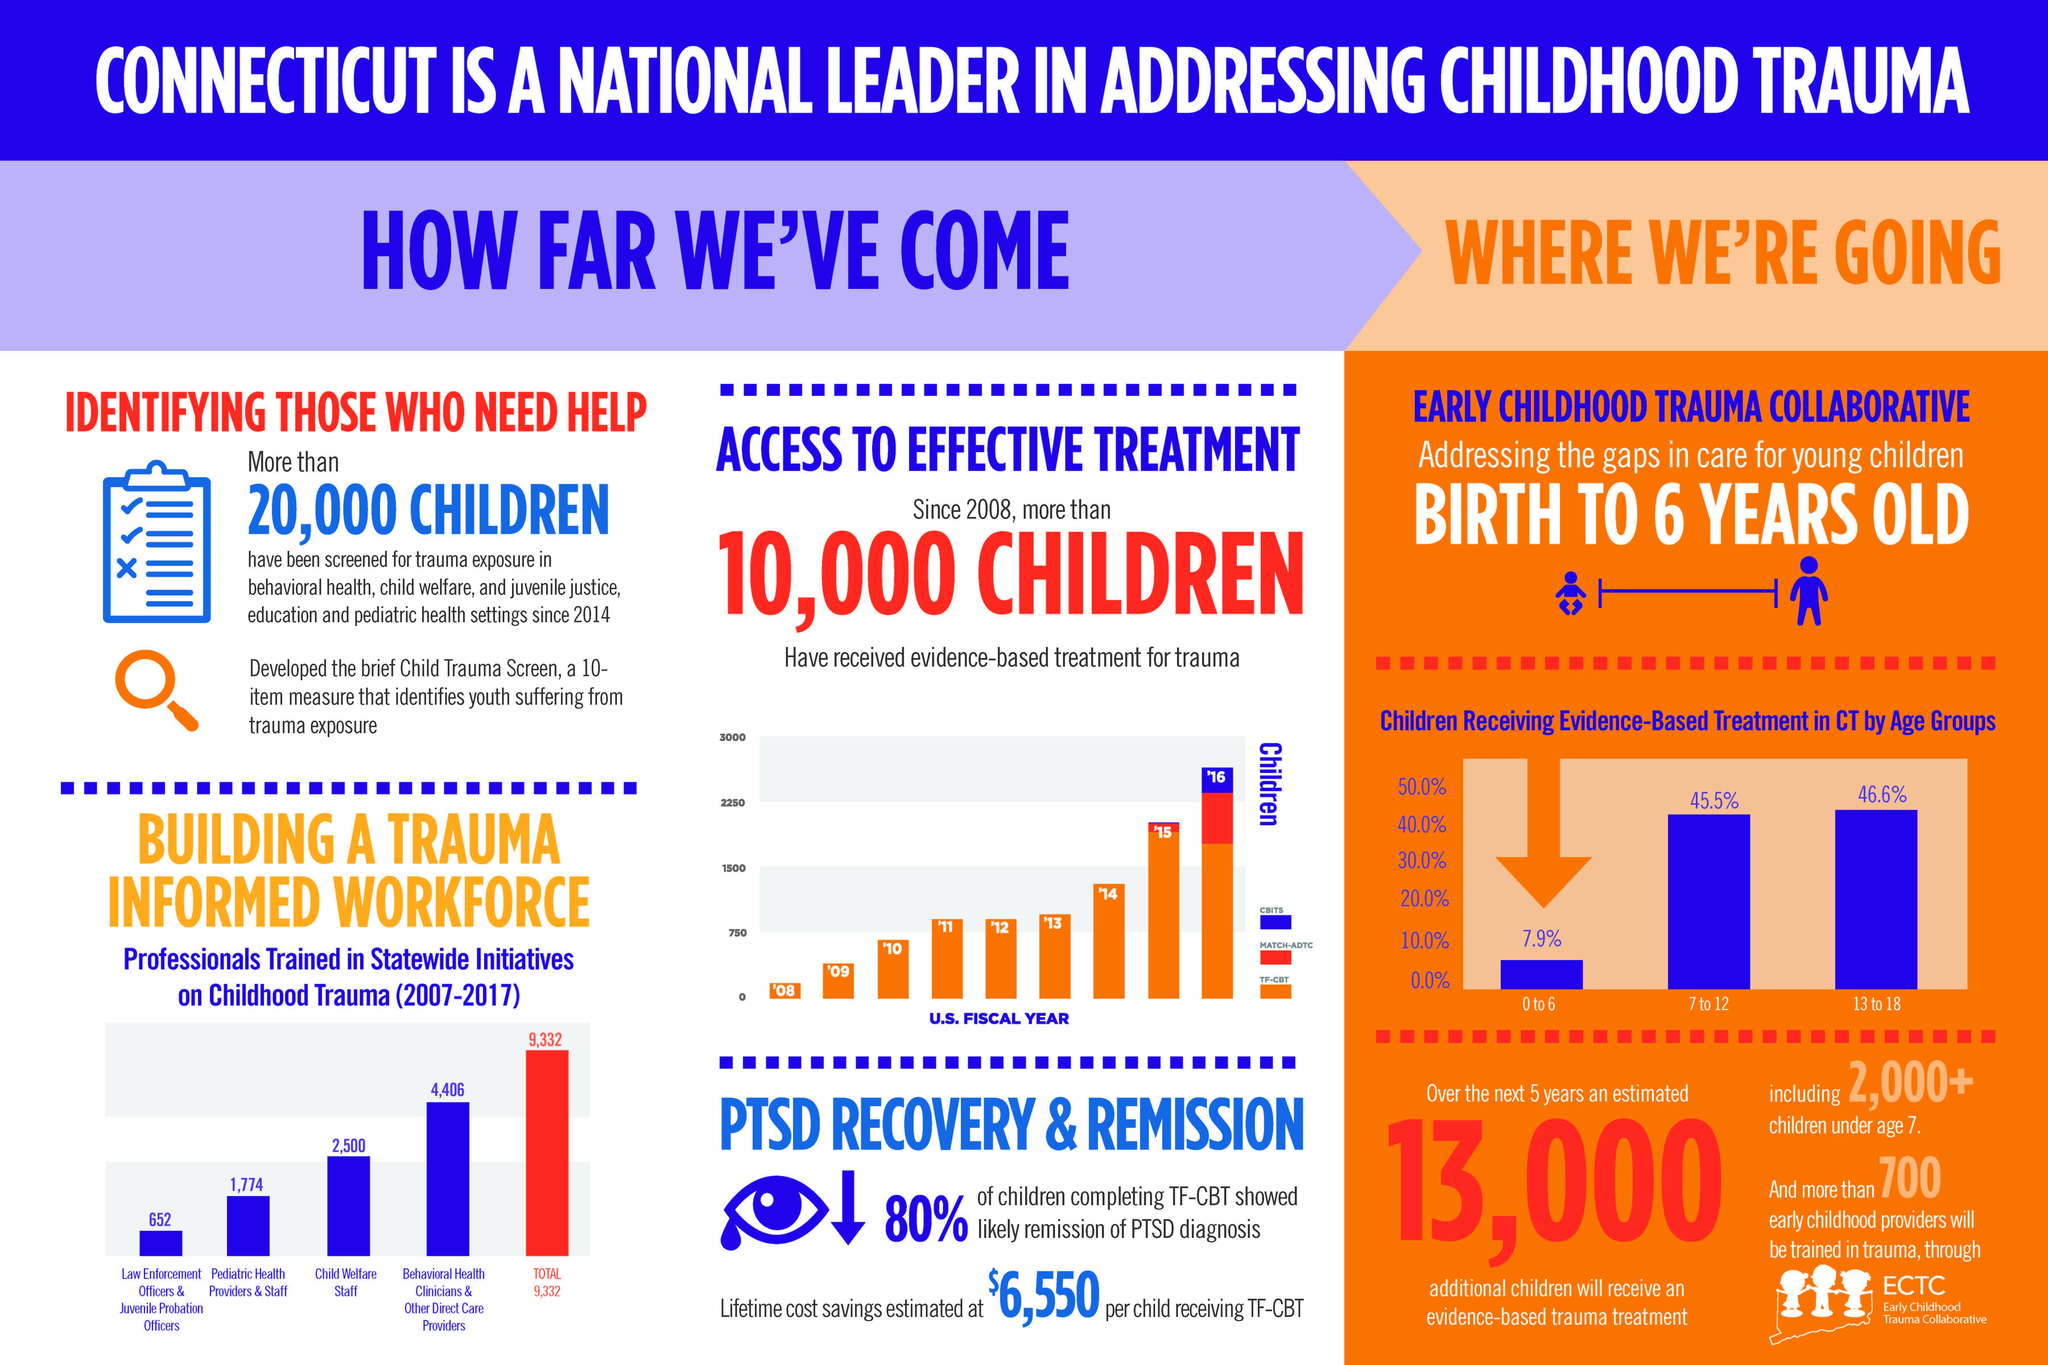List a handful of essential elements in this visual. In total, 6,180 individuals have been trained as behavioral health clinicians and pediatric health providers. The age group of children receiving the second highest percentage of evidence-based treatment is 7 to 12 years old. 